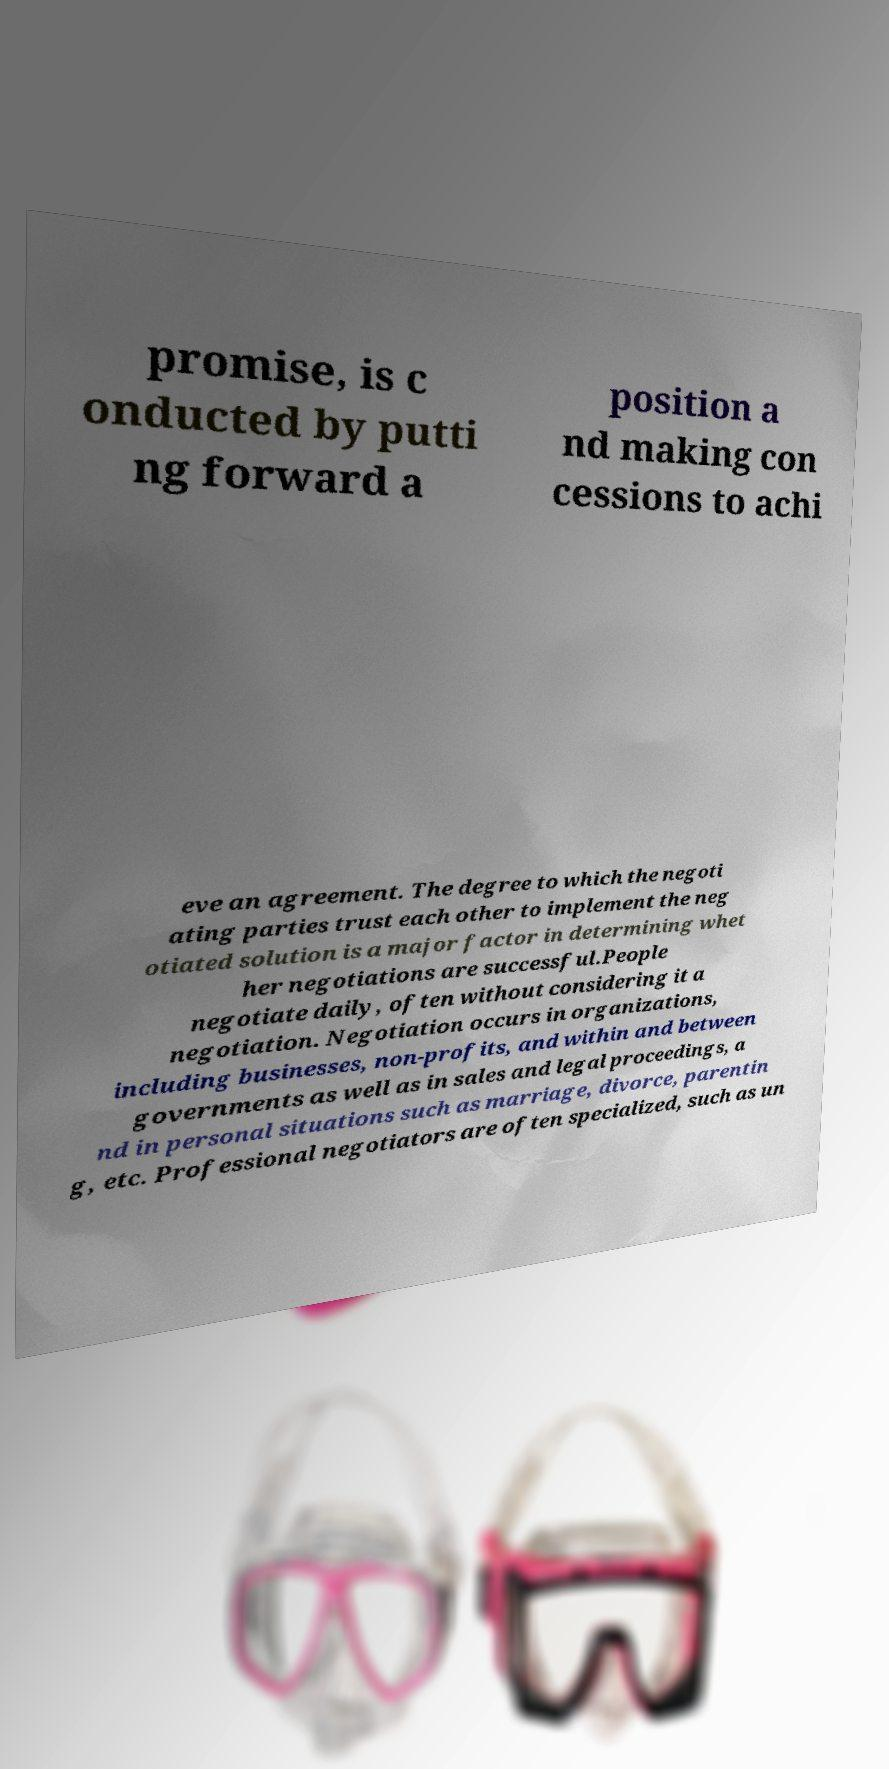What messages or text are displayed in this image? I need them in a readable, typed format. promise, is c onducted by putti ng forward a position a nd making con cessions to achi eve an agreement. The degree to which the negoti ating parties trust each other to implement the neg otiated solution is a major factor in determining whet her negotiations are successful.People negotiate daily, often without considering it a negotiation. Negotiation occurs in organizations, including businesses, non-profits, and within and between governments as well as in sales and legal proceedings, a nd in personal situations such as marriage, divorce, parentin g, etc. Professional negotiators are often specialized, such as un 